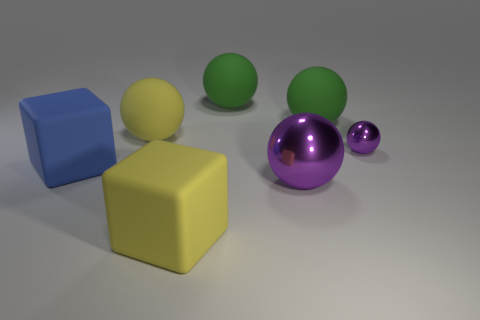Can you describe the arrangement of the objects in the image? Certainly! In the image, we see a collection of geometric shapes arranged on a flat surface. On the left, there's a blue cube and a yellow cube. To the right, there are four spheres, with one large purple sphere, two smaller green spheres, and a small purple sphere. The composition suggests an intentional and balanced arrangement, with colors and sizes creating a visually pleasing contrast. 